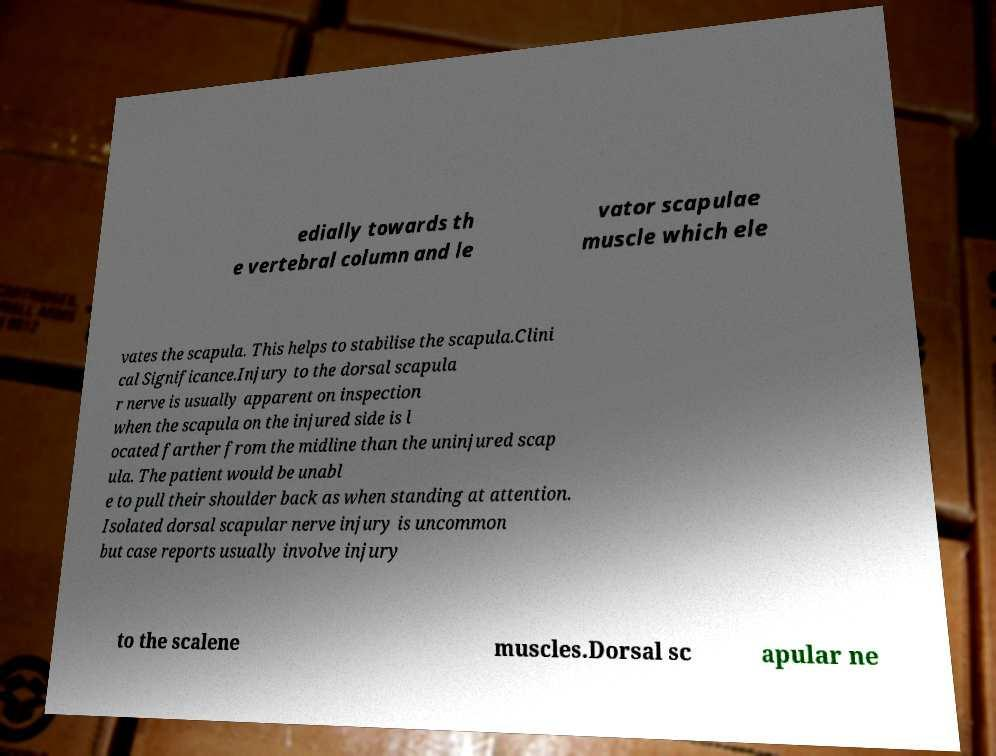For documentation purposes, I need the text within this image transcribed. Could you provide that? edially towards th e vertebral column and le vator scapulae muscle which ele vates the scapula. This helps to stabilise the scapula.Clini cal Significance.Injury to the dorsal scapula r nerve is usually apparent on inspection when the scapula on the injured side is l ocated farther from the midline than the uninjured scap ula. The patient would be unabl e to pull their shoulder back as when standing at attention. Isolated dorsal scapular nerve injury is uncommon but case reports usually involve injury to the scalene muscles.Dorsal sc apular ne 